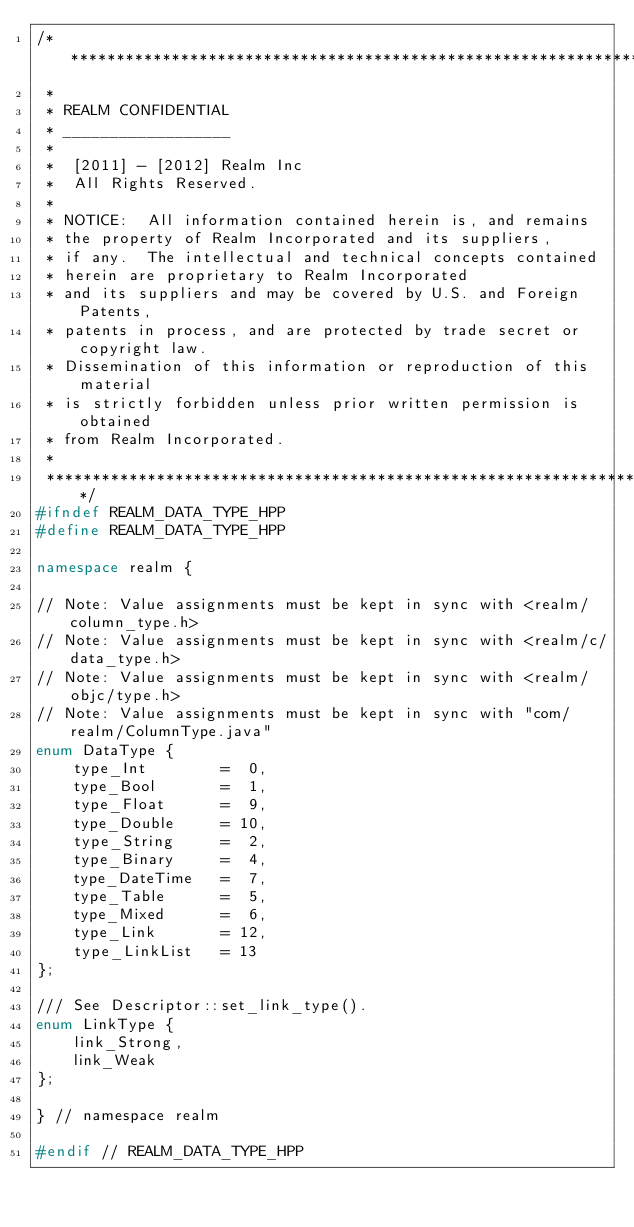Convert code to text. <code><loc_0><loc_0><loc_500><loc_500><_C++_>/*************************************************************************
 *
 * REALM CONFIDENTIAL
 * __________________
 *
 *  [2011] - [2012] Realm Inc
 *  All Rights Reserved.
 *
 * NOTICE:  All information contained herein is, and remains
 * the property of Realm Incorporated and its suppliers,
 * if any.  The intellectual and technical concepts contained
 * herein are proprietary to Realm Incorporated
 * and its suppliers and may be covered by U.S. and Foreign Patents,
 * patents in process, and are protected by trade secret or copyright law.
 * Dissemination of this information or reproduction of this material
 * is strictly forbidden unless prior written permission is obtained
 * from Realm Incorporated.
 *
 **************************************************************************/
#ifndef REALM_DATA_TYPE_HPP
#define REALM_DATA_TYPE_HPP

namespace realm {

// Note: Value assignments must be kept in sync with <realm/column_type.h>
// Note: Value assignments must be kept in sync with <realm/c/data_type.h>
// Note: Value assignments must be kept in sync with <realm/objc/type.h>
// Note: Value assignments must be kept in sync with "com/realm/ColumnType.java"
enum DataType {
    type_Int        =  0,
    type_Bool       =  1,
    type_Float      =  9,
    type_Double     = 10,
    type_String     =  2,
    type_Binary     =  4,
    type_DateTime   =  7,
    type_Table      =  5,
    type_Mixed      =  6,
    type_Link       = 12,
    type_LinkList   = 13
};

/// See Descriptor::set_link_type().
enum LinkType {
    link_Strong,
    link_Weak
};

} // namespace realm

#endif // REALM_DATA_TYPE_HPP
</code> 